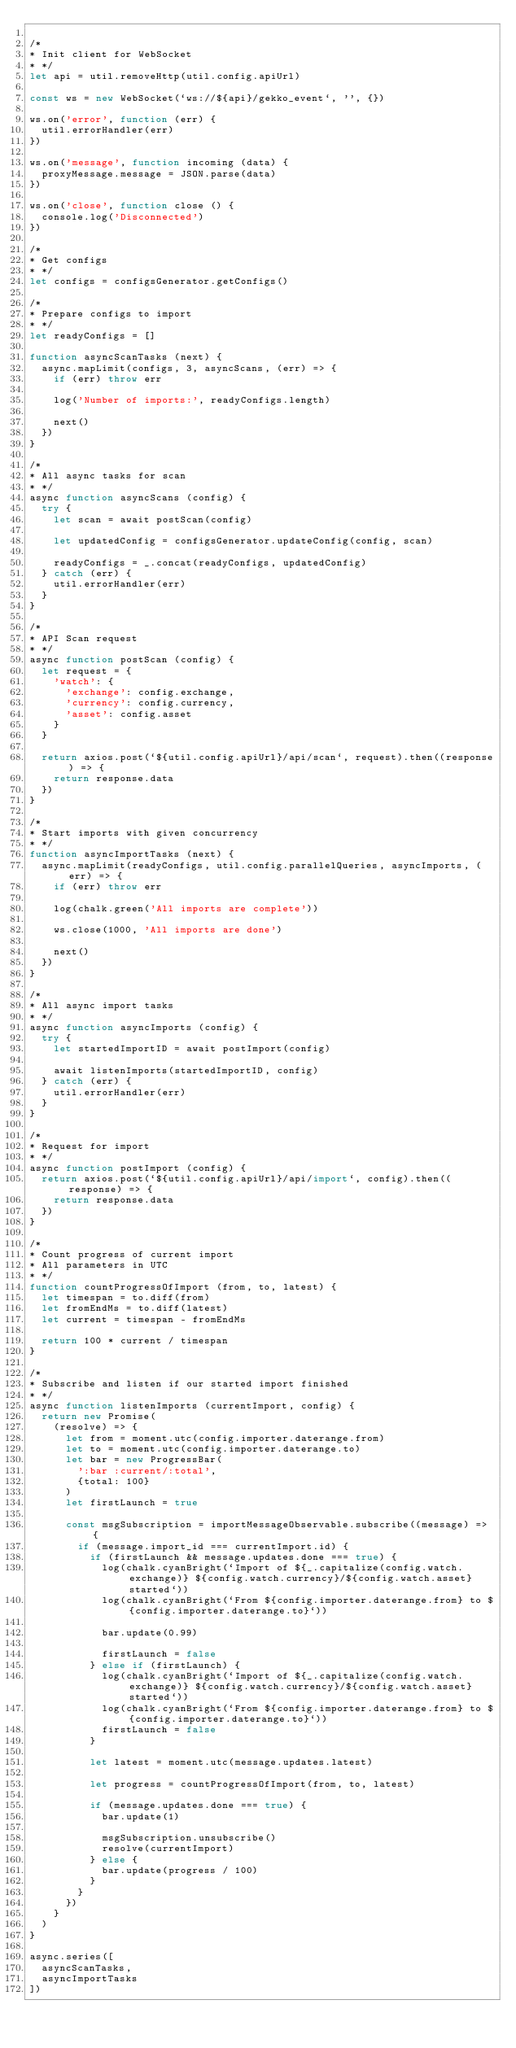Convert code to text. <code><loc_0><loc_0><loc_500><loc_500><_JavaScript_>
/*
* Init client for WebSocket
* */
let api = util.removeHttp(util.config.apiUrl)

const ws = new WebSocket(`ws://${api}/gekko_event`, '', {})

ws.on('error', function (err) {
  util.errorHandler(err)
})

ws.on('message', function incoming (data) {
  proxyMessage.message = JSON.parse(data)
})

ws.on('close', function close () {
  console.log('Disconnected')
})

/*
* Get configs
* */
let configs = configsGenerator.getConfigs()

/*
* Prepare configs to import
* */
let readyConfigs = []

function asyncScanTasks (next) {
  async.mapLimit(configs, 3, asyncScans, (err) => {
    if (err) throw err

    log('Number of imports:', readyConfigs.length)

    next()
  })
}

/*
* All async tasks for scan
* */
async function asyncScans (config) {
  try {
    let scan = await postScan(config)

    let updatedConfig = configsGenerator.updateConfig(config, scan)

    readyConfigs = _.concat(readyConfigs, updatedConfig)
  } catch (err) {
    util.errorHandler(err)
  }
}

/*
* API Scan request
* */
async function postScan (config) {
  let request = {
    'watch': {
      'exchange': config.exchange,
      'currency': config.currency,
      'asset': config.asset
    }
  }

  return axios.post(`${util.config.apiUrl}/api/scan`, request).then((response) => {
    return response.data
  })
}

/*
* Start imports with given concurrency
* */
function asyncImportTasks (next) {
  async.mapLimit(readyConfigs, util.config.parallelQueries, asyncImports, (err) => {
    if (err) throw err

    log(chalk.green('All imports are complete'))

    ws.close(1000, 'All imports are done')

    next()
  })
}

/*
* All async import tasks
* */
async function asyncImports (config) {
  try {
    let startedImportID = await postImport(config)

    await listenImports(startedImportID, config)
  } catch (err) {
    util.errorHandler(err)
  }
}

/*
* Request for import
* */
async function postImport (config) {
  return axios.post(`${util.config.apiUrl}/api/import`, config).then((response) => {
    return response.data
  })
}

/*
* Count progress of current import
* All parameters in UTC
* */
function countProgressOfImport (from, to, latest) {
  let timespan = to.diff(from)
  let fromEndMs = to.diff(latest)
  let current = timespan - fromEndMs

  return 100 * current / timespan
}

/*
* Subscribe and listen if our started import finished
* */
async function listenImports (currentImport, config) {
  return new Promise(
    (resolve) => {
      let from = moment.utc(config.importer.daterange.from)
      let to = moment.utc(config.importer.daterange.to)
      let bar = new ProgressBar(
        ':bar :current/:total',
        {total: 100}
      )
      let firstLaunch = true

      const msgSubscription = importMessageObservable.subscribe((message) => {
        if (message.import_id === currentImport.id) {
          if (firstLaunch && message.updates.done === true) {
            log(chalk.cyanBright(`Import of ${_.capitalize(config.watch.exchange)} ${config.watch.currency}/${config.watch.asset} started`))
            log(chalk.cyanBright(`From ${config.importer.daterange.from} to ${config.importer.daterange.to}`))

            bar.update(0.99)

            firstLaunch = false
          } else if (firstLaunch) {
            log(chalk.cyanBright(`Import of ${_.capitalize(config.watch.exchange)} ${config.watch.currency}/${config.watch.asset} started`))
            log(chalk.cyanBright(`From ${config.importer.daterange.from} to ${config.importer.daterange.to}`))
            firstLaunch = false
          }

          let latest = moment.utc(message.updates.latest)

          let progress = countProgressOfImport(from, to, latest)

          if (message.updates.done === true) {
            bar.update(1)

            msgSubscription.unsubscribe()
            resolve(currentImport)
          } else {
            bar.update(progress / 100)
          }
        }
      })
    }
  )
}

async.series([
  asyncScanTasks,
  asyncImportTasks
])
</code> 